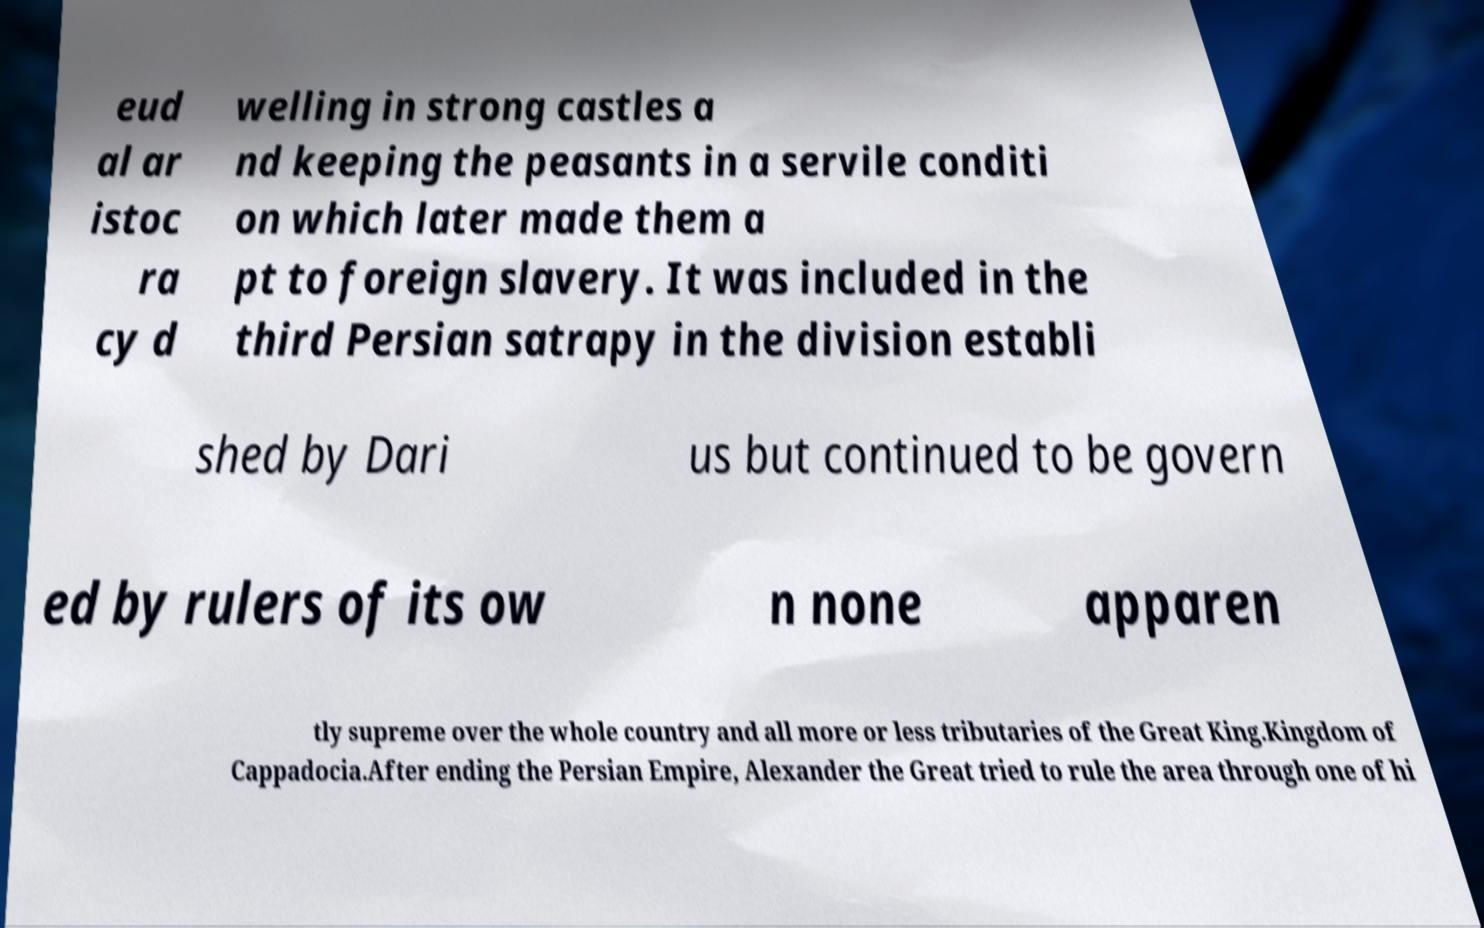Could you extract and type out the text from this image? eud al ar istoc ra cy d welling in strong castles a nd keeping the peasants in a servile conditi on which later made them a pt to foreign slavery. It was included in the third Persian satrapy in the division establi shed by Dari us but continued to be govern ed by rulers of its ow n none apparen tly supreme over the whole country and all more or less tributaries of the Great King.Kingdom of Cappadocia.After ending the Persian Empire, Alexander the Great tried to rule the area through one of hi 